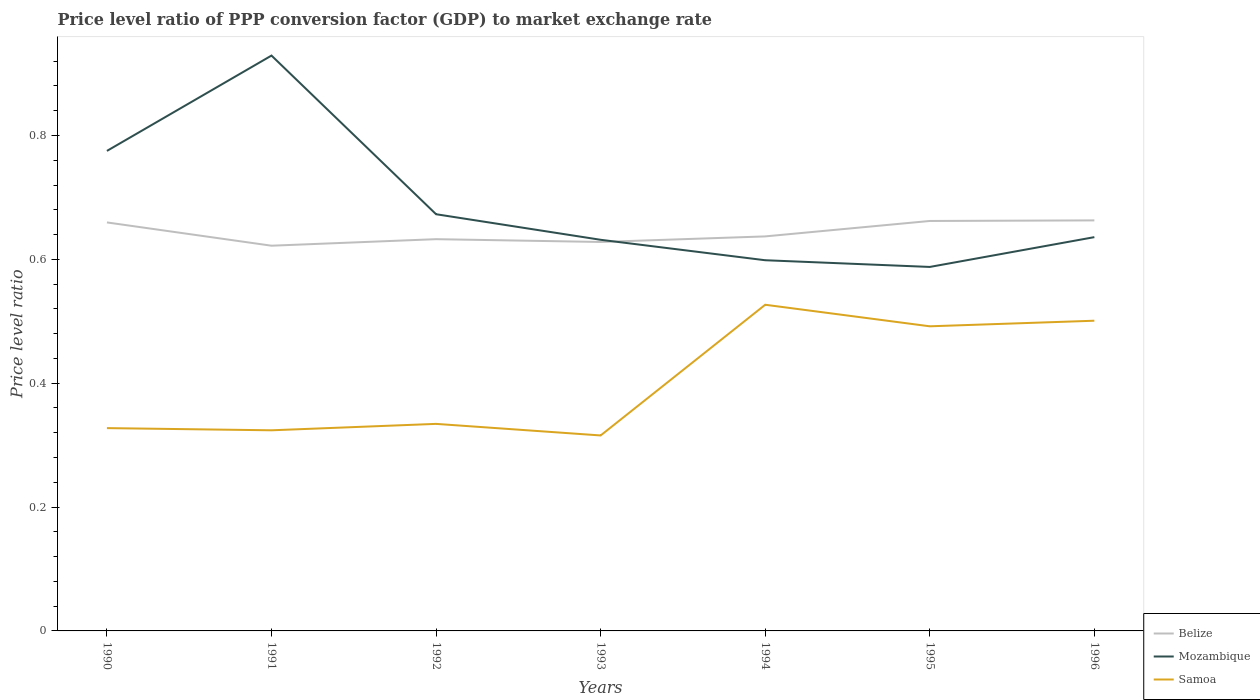How many different coloured lines are there?
Give a very brief answer. 3. Is the number of lines equal to the number of legend labels?
Your answer should be compact. Yes. Across all years, what is the maximum price level ratio in Mozambique?
Keep it short and to the point. 0.59. What is the total price level ratio in Mozambique in the graph?
Provide a succinct answer. 0.29. What is the difference between the highest and the second highest price level ratio in Belize?
Provide a short and direct response. 0.04. What is the difference between the highest and the lowest price level ratio in Mozambique?
Make the answer very short. 2. How many years are there in the graph?
Your answer should be very brief. 7. Does the graph contain grids?
Your answer should be compact. No. How are the legend labels stacked?
Offer a terse response. Vertical. What is the title of the graph?
Provide a succinct answer. Price level ratio of PPP conversion factor (GDP) to market exchange rate. Does "Ethiopia" appear as one of the legend labels in the graph?
Keep it short and to the point. No. What is the label or title of the Y-axis?
Ensure brevity in your answer.  Price level ratio. What is the Price level ratio in Belize in 1990?
Offer a very short reply. 0.66. What is the Price level ratio in Mozambique in 1990?
Offer a terse response. 0.78. What is the Price level ratio of Samoa in 1990?
Make the answer very short. 0.33. What is the Price level ratio in Belize in 1991?
Your answer should be compact. 0.62. What is the Price level ratio in Mozambique in 1991?
Offer a terse response. 0.93. What is the Price level ratio in Samoa in 1991?
Offer a terse response. 0.32. What is the Price level ratio in Belize in 1992?
Provide a short and direct response. 0.63. What is the Price level ratio of Mozambique in 1992?
Give a very brief answer. 0.67. What is the Price level ratio of Samoa in 1992?
Ensure brevity in your answer.  0.33. What is the Price level ratio in Belize in 1993?
Ensure brevity in your answer.  0.63. What is the Price level ratio in Mozambique in 1993?
Provide a short and direct response. 0.63. What is the Price level ratio in Samoa in 1993?
Give a very brief answer. 0.32. What is the Price level ratio in Belize in 1994?
Provide a short and direct response. 0.64. What is the Price level ratio in Mozambique in 1994?
Offer a very short reply. 0.6. What is the Price level ratio in Samoa in 1994?
Offer a terse response. 0.53. What is the Price level ratio in Belize in 1995?
Give a very brief answer. 0.66. What is the Price level ratio in Mozambique in 1995?
Make the answer very short. 0.59. What is the Price level ratio in Samoa in 1995?
Keep it short and to the point. 0.49. What is the Price level ratio in Belize in 1996?
Provide a short and direct response. 0.66. What is the Price level ratio of Mozambique in 1996?
Your answer should be compact. 0.64. What is the Price level ratio in Samoa in 1996?
Make the answer very short. 0.5. Across all years, what is the maximum Price level ratio of Belize?
Your response must be concise. 0.66. Across all years, what is the maximum Price level ratio in Mozambique?
Your answer should be very brief. 0.93. Across all years, what is the maximum Price level ratio of Samoa?
Your response must be concise. 0.53. Across all years, what is the minimum Price level ratio in Belize?
Offer a very short reply. 0.62. Across all years, what is the minimum Price level ratio in Mozambique?
Your answer should be very brief. 0.59. Across all years, what is the minimum Price level ratio of Samoa?
Your answer should be compact. 0.32. What is the total Price level ratio of Belize in the graph?
Offer a terse response. 4.5. What is the total Price level ratio in Mozambique in the graph?
Offer a very short reply. 4.83. What is the total Price level ratio in Samoa in the graph?
Make the answer very short. 2.82. What is the difference between the Price level ratio of Belize in 1990 and that in 1991?
Offer a very short reply. 0.04. What is the difference between the Price level ratio of Mozambique in 1990 and that in 1991?
Ensure brevity in your answer.  -0.15. What is the difference between the Price level ratio of Samoa in 1990 and that in 1991?
Provide a succinct answer. 0. What is the difference between the Price level ratio in Belize in 1990 and that in 1992?
Make the answer very short. 0.03. What is the difference between the Price level ratio of Mozambique in 1990 and that in 1992?
Make the answer very short. 0.1. What is the difference between the Price level ratio of Samoa in 1990 and that in 1992?
Offer a very short reply. -0.01. What is the difference between the Price level ratio of Belize in 1990 and that in 1993?
Keep it short and to the point. 0.03. What is the difference between the Price level ratio of Mozambique in 1990 and that in 1993?
Your answer should be very brief. 0.14. What is the difference between the Price level ratio of Samoa in 1990 and that in 1993?
Make the answer very short. 0.01. What is the difference between the Price level ratio of Belize in 1990 and that in 1994?
Your answer should be compact. 0.02. What is the difference between the Price level ratio of Mozambique in 1990 and that in 1994?
Keep it short and to the point. 0.18. What is the difference between the Price level ratio in Samoa in 1990 and that in 1994?
Keep it short and to the point. -0.2. What is the difference between the Price level ratio in Belize in 1990 and that in 1995?
Your answer should be very brief. -0. What is the difference between the Price level ratio in Mozambique in 1990 and that in 1995?
Ensure brevity in your answer.  0.19. What is the difference between the Price level ratio of Samoa in 1990 and that in 1995?
Keep it short and to the point. -0.16. What is the difference between the Price level ratio in Belize in 1990 and that in 1996?
Offer a very short reply. -0. What is the difference between the Price level ratio in Mozambique in 1990 and that in 1996?
Make the answer very short. 0.14. What is the difference between the Price level ratio in Samoa in 1990 and that in 1996?
Keep it short and to the point. -0.17. What is the difference between the Price level ratio in Belize in 1991 and that in 1992?
Your response must be concise. -0.01. What is the difference between the Price level ratio in Mozambique in 1991 and that in 1992?
Offer a very short reply. 0.26. What is the difference between the Price level ratio of Samoa in 1991 and that in 1992?
Provide a short and direct response. -0.01. What is the difference between the Price level ratio of Belize in 1991 and that in 1993?
Your answer should be compact. -0.01. What is the difference between the Price level ratio in Mozambique in 1991 and that in 1993?
Provide a succinct answer. 0.3. What is the difference between the Price level ratio in Samoa in 1991 and that in 1993?
Offer a very short reply. 0.01. What is the difference between the Price level ratio of Belize in 1991 and that in 1994?
Offer a terse response. -0.01. What is the difference between the Price level ratio of Mozambique in 1991 and that in 1994?
Offer a terse response. 0.33. What is the difference between the Price level ratio in Samoa in 1991 and that in 1994?
Your answer should be compact. -0.2. What is the difference between the Price level ratio in Belize in 1991 and that in 1995?
Provide a short and direct response. -0.04. What is the difference between the Price level ratio of Mozambique in 1991 and that in 1995?
Offer a terse response. 0.34. What is the difference between the Price level ratio of Samoa in 1991 and that in 1995?
Your response must be concise. -0.17. What is the difference between the Price level ratio of Belize in 1991 and that in 1996?
Provide a succinct answer. -0.04. What is the difference between the Price level ratio in Mozambique in 1991 and that in 1996?
Offer a terse response. 0.29. What is the difference between the Price level ratio in Samoa in 1991 and that in 1996?
Make the answer very short. -0.18. What is the difference between the Price level ratio of Belize in 1992 and that in 1993?
Offer a terse response. 0. What is the difference between the Price level ratio in Mozambique in 1992 and that in 1993?
Keep it short and to the point. 0.04. What is the difference between the Price level ratio in Samoa in 1992 and that in 1993?
Make the answer very short. 0.02. What is the difference between the Price level ratio of Belize in 1992 and that in 1994?
Offer a very short reply. -0. What is the difference between the Price level ratio in Mozambique in 1992 and that in 1994?
Offer a very short reply. 0.07. What is the difference between the Price level ratio in Samoa in 1992 and that in 1994?
Provide a succinct answer. -0.19. What is the difference between the Price level ratio in Belize in 1992 and that in 1995?
Ensure brevity in your answer.  -0.03. What is the difference between the Price level ratio in Mozambique in 1992 and that in 1995?
Keep it short and to the point. 0.09. What is the difference between the Price level ratio in Samoa in 1992 and that in 1995?
Provide a short and direct response. -0.16. What is the difference between the Price level ratio in Belize in 1992 and that in 1996?
Your answer should be compact. -0.03. What is the difference between the Price level ratio of Mozambique in 1992 and that in 1996?
Your answer should be very brief. 0.04. What is the difference between the Price level ratio of Samoa in 1992 and that in 1996?
Provide a succinct answer. -0.17. What is the difference between the Price level ratio of Belize in 1993 and that in 1994?
Give a very brief answer. -0.01. What is the difference between the Price level ratio of Mozambique in 1993 and that in 1994?
Make the answer very short. 0.03. What is the difference between the Price level ratio of Samoa in 1993 and that in 1994?
Keep it short and to the point. -0.21. What is the difference between the Price level ratio in Belize in 1993 and that in 1995?
Keep it short and to the point. -0.03. What is the difference between the Price level ratio of Mozambique in 1993 and that in 1995?
Keep it short and to the point. 0.04. What is the difference between the Price level ratio in Samoa in 1993 and that in 1995?
Offer a terse response. -0.18. What is the difference between the Price level ratio of Belize in 1993 and that in 1996?
Keep it short and to the point. -0.03. What is the difference between the Price level ratio in Mozambique in 1993 and that in 1996?
Provide a short and direct response. -0. What is the difference between the Price level ratio in Samoa in 1993 and that in 1996?
Make the answer very short. -0.19. What is the difference between the Price level ratio in Belize in 1994 and that in 1995?
Your answer should be compact. -0.02. What is the difference between the Price level ratio in Mozambique in 1994 and that in 1995?
Your answer should be compact. 0.01. What is the difference between the Price level ratio of Samoa in 1994 and that in 1995?
Make the answer very short. 0.03. What is the difference between the Price level ratio of Belize in 1994 and that in 1996?
Give a very brief answer. -0.03. What is the difference between the Price level ratio of Mozambique in 1994 and that in 1996?
Offer a terse response. -0.04. What is the difference between the Price level ratio of Samoa in 1994 and that in 1996?
Offer a very short reply. 0.03. What is the difference between the Price level ratio in Belize in 1995 and that in 1996?
Give a very brief answer. -0. What is the difference between the Price level ratio in Mozambique in 1995 and that in 1996?
Provide a short and direct response. -0.05. What is the difference between the Price level ratio in Samoa in 1995 and that in 1996?
Make the answer very short. -0.01. What is the difference between the Price level ratio of Belize in 1990 and the Price level ratio of Mozambique in 1991?
Offer a very short reply. -0.27. What is the difference between the Price level ratio in Belize in 1990 and the Price level ratio in Samoa in 1991?
Offer a terse response. 0.34. What is the difference between the Price level ratio in Mozambique in 1990 and the Price level ratio in Samoa in 1991?
Provide a short and direct response. 0.45. What is the difference between the Price level ratio in Belize in 1990 and the Price level ratio in Mozambique in 1992?
Provide a succinct answer. -0.01. What is the difference between the Price level ratio in Belize in 1990 and the Price level ratio in Samoa in 1992?
Ensure brevity in your answer.  0.33. What is the difference between the Price level ratio in Mozambique in 1990 and the Price level ratio in Samoa in 1992?
Make the answer very short. 0.44. What is the difference between the Price level ratio of Belize in 1990 and the Price level ratio of Mozambique in 1993?
Ensure brevity in your answer.  0.03. What is the difference between the Price level ratio of Belize in 1990 and the Price level ratio of Samoa in 1993?
Your answer should be compact. 0.34. What is the difference between the Price level ratio of Mozambique in 1990 and the Price level ratio of Samoa in 1993?
Offer a terse response. 0.46. What is the difference between the Price level ratio in Belize in 1990 and the Price level ratio in Mozambique in 1994?
Provide a short and direct response. 0.06. What is the difference between the Price level ratio in Belize in 1990 and the Price level ratio in Samoa in 1994?
Your response must be concise. 0.13. What is the difference between the Price level ratio of Mozambique in 1990 and the Price level ratio of Samoa in 1994?
Offer a terse response. 0.25. What is the difference between the Price level ratio in Belize in 1990 and the Price level ratio in Mozambique in 1995?
Provide a succinct answer. 0.07. What is the difference between the Price level ratio of Belize in 1990 and the Price level ratio of Samoa in 1995?
Offer a terse response. 0.17. What is the difference between the Price level ratio of Mozambique in 1990 and the Price level ratio of Samoa in 1995?
Your response must be concise. 0.28. What is the difference between the Price level ratio in Belize in 1990 and the Price level ratio in Mozambique in 1996?
Keep it short and to the point. 0.02. What is the difference between the Price level ratio in Belize in 1990 and the Price level ratio in Samoa in 1996?
Keep it short and to the point. 0.16. What is the difference between the Price level ratio in Mozambique in 1990 and the Price level ratio in Samoa in 1996?
Make the answer very short. 0.27. What is the difference between the Price level ratio of Belize in 1991 and the Price level ratio of Mozambique in 1992?
Offer a terse response. -0.05. What is the difference between the Price level ratio in Belize in 1991 and the Price level ratio in Samoa in 1992?
Your answer should be compact. 0.29. What is the difference between the Price level ratio in Mozambique in 1991 and the Price level ratio in Samoa in 1992?
Your response must be concise. 0.59. What is the difference between the Price level ratio in Belize in 1991 and the Price level ratio in Mozambique in 1993?
Make the answer very short. -0.01. What is the difference between the Price level ratio of Belize in 1991 and the Price level ratio of Samoa in 1993?
Provide a short and direct response. 0.31. What is the difference between the Price level ratio in Mozambique in 1991 and the Price level ratio in Samoa in 1993?
Give a very brief answer. 0.61. What is the difference between the Price level ratio in Belize in 1991 and the Price level ratio in Mozambique in 1994?
Offer a terse response. 0.02. What is the difference between the Price level ratio in Belize in 1991 and the Price level ratio in Samoa in 1994?
Your answer should be compact. 0.1. What is the difference between the Price level ratio of Mozambique in 1991 and the Price level ratio of Samoa in 1994?
Provide a succinct answer. 0.4. What is the difference between the Price level ratio in Belize in 1991 and the Price level ratio in Mozambique in 1995?
Offer a terse response. 0.03. What is the difference between the Price level ratio of Belize in 1991 and the Price level ratio of Samoa in 1995?
Ensure brevity in your answer.  0.13. What is the difference between the Price level ratio of Mozambique in 1991 and the Price level ratio of Samoa in 1995?
Your answer should be compact. 0.44. What is the difference between the Price level ratio in Belize in 1991 and the Price level ratio in Mozambique in 1996?
Make the answer very short. -0.01. What is the difference between the Price level ratio of Belize in 1991 and the Price level ratio of Samoa in 1996?
Your response must be concise. 0.12. What is the difference between the Price level ratio in Mozambique in 1991 and the Price level ratio in Samoa in 1996?
Your answer should be compact. 0.43. What is the difference between the Price level ratio in Belize in 1992 and the Price level ratio in Samoa in 1993?
Keep it short and to the point. 0.32. What is the difference between the Price level ratio of Mozambique in 1992 and the Price level ratio of Samoa in 1993?
Keep it short and to the point. 0.36. What is the difference between the Price level ratio of Belize in 1992 and the Price level ratio of Mozambique in 1994?
Make the answer very short. 0.03. What is the difference between the Price level ratio of Belize in 1992 and the Price level ratio of Samoa in 1994?
Give a very brief answer. 0.11. What is the difference between the Price level ratio of Mozambique in 1992 and the Price level ratio of Samoa in 1994?
Your answer should be very brief. 0.15. What is the difference between the Price level ratio of Belize in 1992 and the Price level ratio of Mozambique in 1995?
Make the answer very short. 0.04. What is the difference between the Price level ratio in Belize in 1992 and the Price level ratio in Samoa in 1995?
Keep it short and to the point. 0.14. What is the difference between the Price level ratio in Mozambique in 1992 and the Price level ratio in Samoa in 1995?
Ensure brevity in your answer.  0.18. What is the difference between the Price level ratio of Belize in 1992 and the Price level ratio of Mozambique in 1996?
Keep it short and to the point. -0. What is the difference between the Price level ratio of Belize in 1992 and the Price level ratio of Samoa in 1996?
Ensure brevity in your answer.  0.13. What is the difference between the Price level ratio in Mozambique in 1992 and the Price level ratio in Samoa in 1996?
Provide a short and direct response. 0.17. What is the difference between the Price level ratio in Belize in 1993 and the Price level ratio in Mozambique in 1994?
Provide a short and direct response. 0.03. What is the difference between the Price level ratio of Belize in 1993 and the Price level ratio of Samoa in 1994?
Offer a very short reply. 0.1. What is the difference between the Price level ratio of Mozambique in 1993 and the Price level ratio of Samoa in 1994?
Your answer should be compact. 0.1. What is the difference between the Price level ratio of Belize in 1993 and the Price level ratio of Mozambique in 1995?
Give a very brief answer. 0.04. What is the difference between the Price level ratio in Belize in 1993 and the Price level ratio in Samoa in 1995?
Your response must be concise. 0.14. What is the difference between the Price level ratio in Mozambique in 1993 and the Price level ratio in Samoa in 1995?
Your answer should be very brief. 0.14. What is the difference between the Price level ratio in Belize in 1993 and the Price level ratio in Mozambique in 1996?
Offer a terse response. -0.01. What is the difference between the Price level ratio in Belize in 1993 and the Price level ratio in Samoa in 1996?
Your answer should be compact. 0.13. What is the difference between the Price level ratio in Mozambique in 1993 and the Price level ratio in Samoa in 1996?
Your answer should be very brief. 0.13. What is the difference between the Price level ratio of Belize in 1994 and the Price level ratio of Mozambique in 1995?
Ensure brevity in your answer.  0.05. What is the difference between the Price level ratio of Belize in 1994 and the Price level ratio of Samoa in 1995?
Keep it short and to the point. 0.15. What is the difference between the Price level ratio of Mozambique in 1994 and the Price level ratio of Samoa in 1995?
Offer a terse response. 0.11. What is the difference between the Price level ratio in Belize in 1994 and the Price level ratio in Mozambique in 1996?
Offer a terse response. 0. What is the difference between the Price level ratio in Belize in 1994 and the Price level ratio in Samoa in 1996?
Give a very brief answer. 0.14. What is the difference between the Price level ratio of Mozambique in 1994 and the Price level ratio of Samoa in 1996?
Offer a very short reply. 0.1. What is the difference between the Price level ratio of Belize in 1995 and the Price level ratio of Mozambique in 1996?
Make the answer very short. 0.03. What is the difference between the Price level ratio of Belize in 1995 and the Price level ratio of Samoa in 1996?
Ensure brevity in your answer.  0.16. What is the difference between the Price level ratio of Mozambique in 1995 and the Price level ratio of Samoa in 1996?
Your response must be concise. 0.09. What is the average Price level ratio in Belize per year?
Offer a very short reply. 0.64. What is the average Price level ratio in Mozambique per year?
Your response must be concise. 0.69. What is the average Price level ratio in Samoa per year?
Provide a succinct answer. 0.4. In the year 1990, what is the difference between the Price level ratio of Belize and Price level ratio of Mozambique?
Keep it short and to the point. -0.12. In the year 1990, what is the difference between the Price level ratio of Belize and Price level ratio of Samoa?
Keep it short and to the point. 0.33. In the year 1990, what is the difference between the Price level ratio of Mozambique and Price level ratio of Samoa?
Make the answer very short. 0.45. In the year 1991, what is the difference between the Price level ratio of Belize and Price level ratio of Mozambique?
Your answer should be very brief. -0.31. In the year 1991, what is the difference between the Price level ratio of Belize and Price level ratio of Samoa?
Your response must be concise. 0.3. In the year 1991, what is the difference between the Price level ratio in Mozambique and Price level ratio in Samoa?
Offer a terse response. 0.61. In the year 1992, what is the difference between the Price level ratio in Belize and Price level ratio in Mozambique?
Offer a very short reply. -0.04. In the year 1992, what is the difference between the Price level ratio in Belize and Price level ratio in Samoa?
Offer a terse response. 0.3. In the year 1992, what is the difference between the Price level ratio of Mozambique and Price level ratio of Samoa?
Ensure brevity in your answer.  0.34. In the year 1993, what is the difference between the Price level ratio in Belize and Price level ratio in Mozambique?
Offer a terse response. -0. In the year 1993, what is the difference between the Price level ratio of Belize and Price level ratio of Samoa?
Offer a very short reply. 0.31. In the year 1993, what is the difference between the Price level ratio of Mozambique and Price level ratio of Samoa?
Your answer should be compact. 0.32. In the year 1994, what is the difference between the Price level ratio in Belize and Price level ratio in Mozambique?
Give a very brief answer. 0.04. In the year 1994, what is the difference between the Price level ratio of Belize and Price level ratio of Samoa?
Give a very brief answer. 0.11. In the year 1994, what is the difference between the Price level ratio in Mozambique and Price level ratio in Samoa?
Give a very brief answer. 0.07. In the year 1995, what is the difference between the Price level ratio in Belize and Price level ratio in Mozambique?
Give a very brief answer. 0.07. In the year 1995, what is the difference between the Price level ratio in Belize and Price level ratio in Samoa?
Provide a succinct answer. 0.17. In the year 1995, what is the difference between the Price level ratio of Mozambique and Price level ratio of Samoa?
Give a very brief answer. 0.1. In the year 1996, what is the difference between the Price level ratio of Belize and Price level ratio of Mozambique?
Offer a terse response. 0.03. In the year 1996, what is the difference between the Price level ratio of Belize and Price level ratio of Samoa?
Your answer should be very brief. 0.16. In the year 1996, what is the difference between the Price level ratio in Mozambique and Price level ratio in Samoa?
Your answer should be very brief. 0.14. What is the ratio of the Price level ratio of Belize in 1990 to that in 1991?
Offer a terse response. 1.06. What is the ratio of the Price level ratio in Mozambique in 1990 to that in 1991?
Your answer should be compact. 0.83. What is the ratio of the Price level ratio in Samoa in 1990 to that in 1991?
Ensure brevity in your answer.  1.01. What is the ratio of the Price level ratio of Belize in 1990 to that in 1992?
Your response must be concise. 1.04. What is the ratio of the Price level ratio in Mozambique in 1990 to that in 1992?
Keep it short and to the point. 1.15. What is the ratio of the Price level ratio of Samoa in 1990 to that in 1992?
Keep it short and to the point. 0.98. What is the ratio of the Price level ratio in Belize in 1990 to that in 1993?
Give a very brief answer. 1.05. What is the ratio of the Price level ratio in Mozambique in 1990 to that in 1993?
Provide a succinct answer. 1.23. What is the ratio of the Price level ratio of Samoa in 1990 to that in 1993?
Ensure brevity in your answer.  1.04. What is the ratio of the Price level ratio of Belize in 1990 to that in 1994?
Offer a very short reply. 1.04. What is the ratio of the Price level ratio of Mozambique in 1990 to that in 1994?
Your answer should be very brief. 1.29. What is the ratio of the Price level ratio of Samoa in 1990 to that in 1994?
Make the answer very short. 0.62. What is the ratio of the Price level ratio of Belize in 1990 to that in 1995?
Provide a short and direct response. 1. What is the ratio of the Price level ratio in Mozambique in 1990 to that in 1995?
Your answer should be compact. 1.32. What is the ratio of the Price level ratio in Samoa in 1990 to that in 1995?
Provide a succinct answer. 0.67. What is the ratio of the Price level ratio of Belize in 1990 to that in 1996?
Your answer should be compact. 1. What is the ratio of the Price level ratio in Mozambique in 1990 to that in 1996?
Make the answer very short. 1.22. What is the ratio of the Price level ratio of Samoa in 1990 to that in 1996?
Provide a succinct answer. 0.65. What is the ratio of the Price level ratio in Belize in 1991 to that in 1992?
Your answer should be compact. 0.98. What is the ratio of the Price level ratio of Mozambique in 1991 to that in 1992?
Your response must be concise. 1.38. What is the ratio of the Price level ratio of Samoa in 1991 to that in 1992?
Provide a succinct answer. 0.97. What is the ratio of the Price level ratio of Belize in 1991 to that in 1993?
Keep it short and to the point. 0.99. What is the ratio of the Price level ratio in Mozambique in 1991 to that in 1993?
Make the answer very short. 1.47. What is the ratio of the Price level ratio in Samoa in 1991 to that in 1993?
Offer a very short reply. 1.03. What is the ratio of the Price level ratio of Belize in 1991 to that in 1994?
Ensure brevity in your answer.  0.98. What is the ratio of the Price level ratio in Mozambique in 1991 to that in 1994?
Keep it short and to the point. 1.55. What is the ratio of the Price level ratio of Samoa in 1991 to that in 1994?
Your response must be concise. 0.62. What is the ratio of the Price level ratio of Belize in 1991 to that in 1995?
Give a very brief answer. 0.94. What is the ratio of the Price level ratio in Mozambique in 1991 to that in 1995?
Give a very brief answer. 1.58. What is the ratio of the Price level ratio of Samoa in 1991 to that in 1995?
Your answer should be compact. 0.66. What is the ratio of the Price level ratio of Belize in 1991 to that in 1996?
Make the answer very short. 0.94. What is the ratio of the Price level ratio of Mozambique in 1991 to that in 1996?
Provide a short and direct response. 1.46. What is the ratio of the Price level ratio in Samoa in 1991 to that in 1996?
Give a very brief answer. 0.65. What is the ratio of the Price level ratio in Mozambique in 1992 to that in 1993?
Provide a succinct answer. 1.07. What is the ratio of the Price level ratio of Samoa in 1992 to that in 1993?
Make the answer very short. 1.06. What is the ratio of the Price level ratio of Belize in 1992 to that in 1994?
Your answer should be compact. 0.99. What is the ratio of the Price level ratio of Mozambique in 1992 to that in 1994?
Provide a short and direct response. 1.12. What is the ratio of the Price level ratio of Samoa in 1992 to that in 1994?
Ensure brevity in your answer.  0.63. What is the ratio of the Price level ratio in Belize in 1992 to that in 1995?
Give a very brief answer. 0.96. What is the ratio of the Price level ratio in Mozambique in 1992 to that in 1995?
Keep it short and to the point. 1.14. What is the ratio of the Price level ratio of Samoa in 1992 to that in 1995?
Provide a short and direct response. 0.68. What is the ratio of the Price level ratio in Belize in 1992 to that in 1996?
Make the answer very short. 0.95. What is the ratio of the Price level ratio in Mozambique in 1992 to that in 1996?
Make the answer very short. 1.06. What is the ratio of the Price level ratio in Samoa in 1992 to that in 1996?
Give a very brief answer. 0.67. What is the ratio of the Price level ratio in Belize in 1993 to that in 1994?
Give a very brief answer. 0.99. What is the ratio of the Price level ratio in Mozambique in 1993 to that in 1994?
Offer a very short reply. 1.06. What is the ratio of the Price level ratio of Samoa in 1993 to that in 1994?
Ensure brevity in your answer.  0.6. What is the ratio of the Price level ratio of Belize in 1993 to that in 1995?
Your answer should be very brief. 0.95. What is the ratio of the Price level ratio of Mozambique in 1993 to that in 1995?
Offer a terse response. 1.07. What is the ratio of the Price level ratio of Samoa in 1993 to that in 1995?
Your answer should be very brief. 0.64. What is the ratio of the Price level ratio of Belize in 1993 to that in 1996?
Offer a terse response. 0.95. What is the ratio of the Price level ratio in Mozambique in 1993 to that in 1996?
Your answer should be compact. 0.99. What is the ratio of the Price level ratio in Samoa in 1993 to that in 1996?
Your response must be concise. 0.63. What is the ratio of the Price level ratio in Belize in 1994 to that in 1995?
Your answer should be very brief. 0.96. What is the ratio of the Price level ratio in Mozambique in 1994 to that in 1995?
Your answer should be very brief. 1.02. What is the ratio of the Price level ratio in Samoa in 1994 to that in 1995?
Your response must be concise. 1.07. What is the ratio of the Price level ratio in Mozambique in 1994 to that in 1996?
Make the answer very short. 0.94. What is the ratio of the Price level ratio in Samoa in 1994 to that in 1996?
Your answer should be compact. 1.05. What is the ratio of the Price level ratio in Mozambique in 1995 to that in 1996?
Keep it short and to the point. 0.92. What is the ratio of the Price level ratio in Samoa in 1995 to that in 1996?
Offer a very short reply. 0.98. What is the difference between the highest and the second highest Price level ratio in Belize?
Offer a terse response. 0. What is the difference between the highest and the second highest Price level ratio of Mozambique?
Ensure brevity in your answer.  0.15. What is the difference between the highest and the second highest Price level ratio in Samoa?
Ensure brevity in your answer.  0.03. What is the difference between the highest and the lowest Price level ratio in Belize?
Provide a succinct answer. 0.04. What is the difference between the highest and the lowest Price level ratio in Mozambique?
Provide a short and direct response. 0.34. What is the difference between the highest and the lowest Price level ratio of Samoa?
Provide a succinct answer. 0.21. 